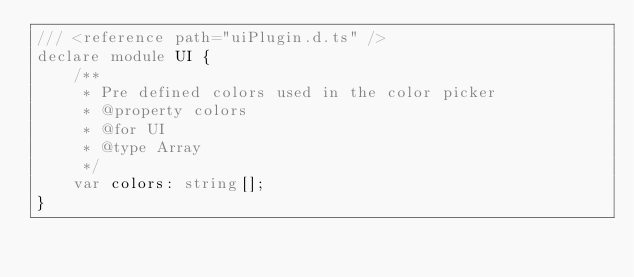Convert code to text. <code><loc_0><loc_0><loc_500><loc_500><_TypeScript_>/// <reference path="uiPlugin.d.ts" />
declare module UI {
    /**
     * Pre defined colors used in the color picker
     * @property colors
     * @for UI
     * @type Array
     */
    var colors: string[];
}
</code> 